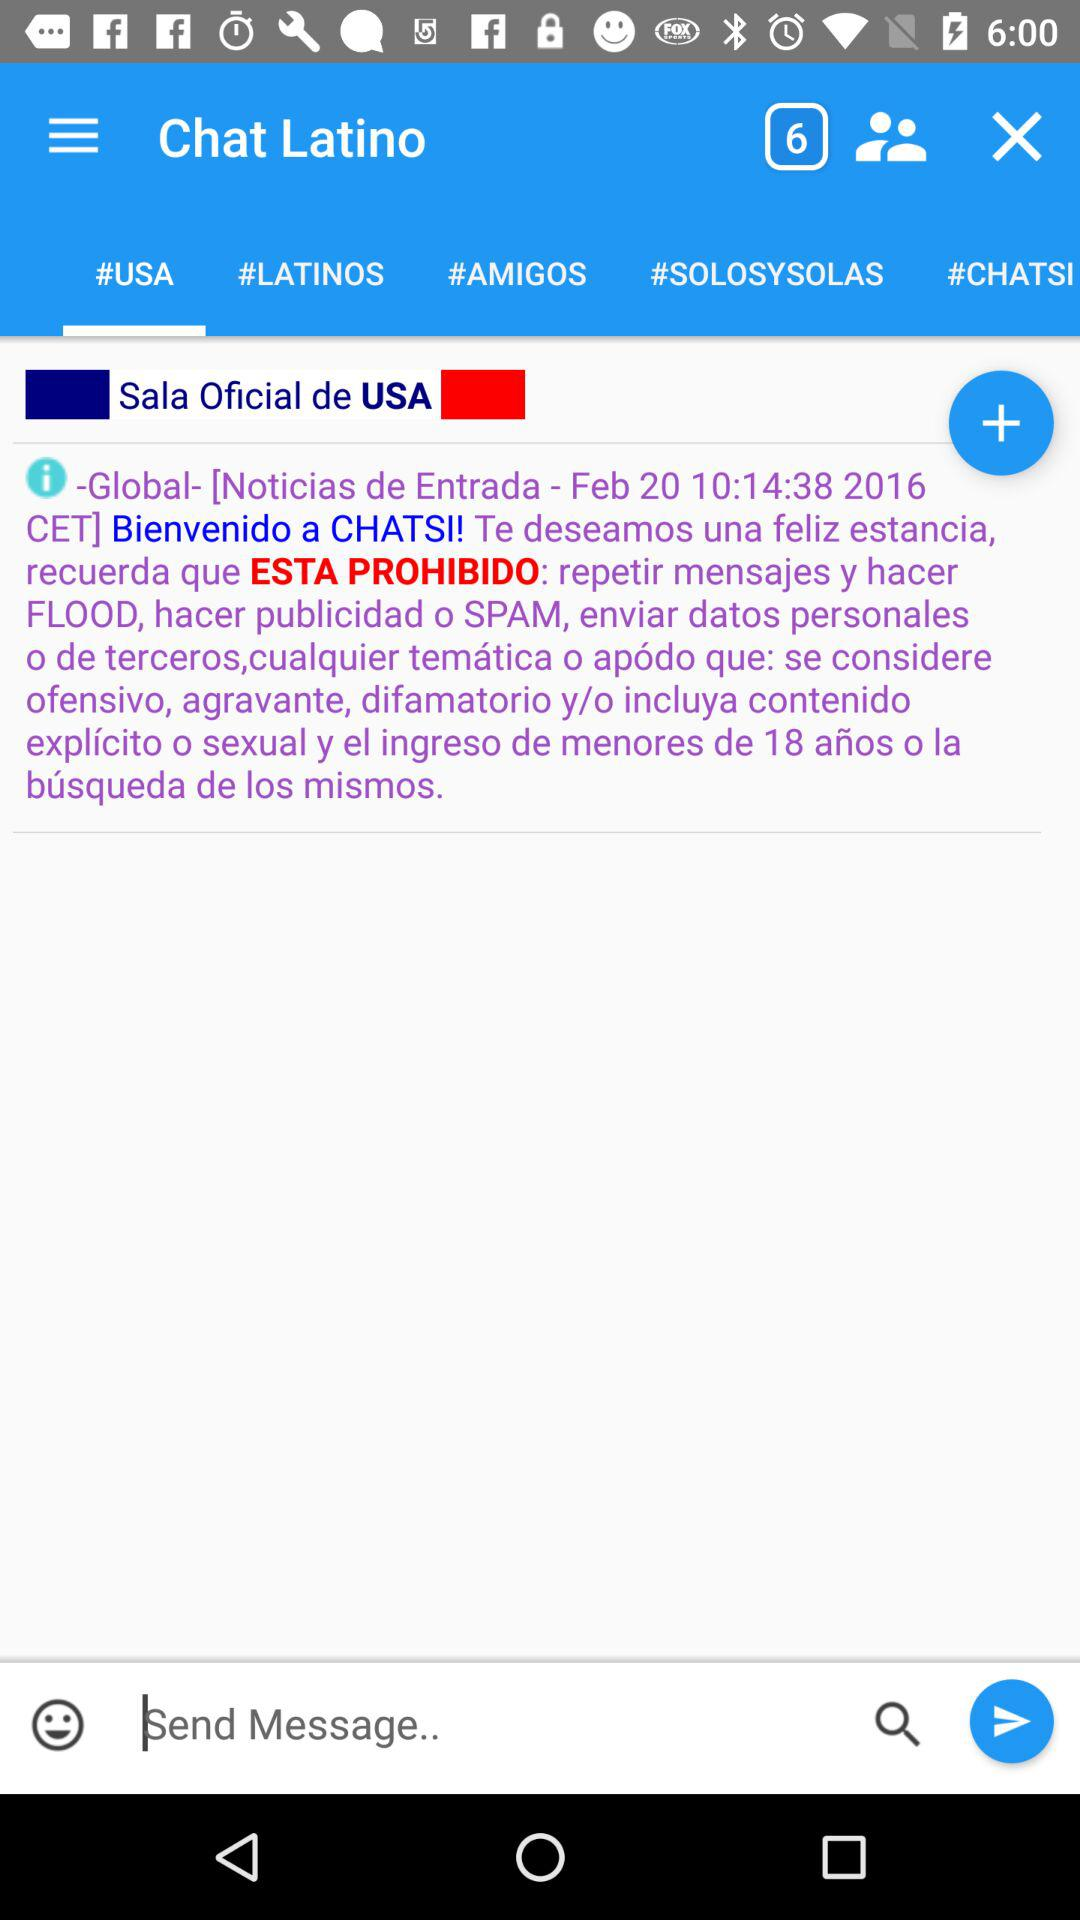When was the last post made in "#LATINOS"?
When the provided information is insufficient, respond with <no answer>. <no answer> 